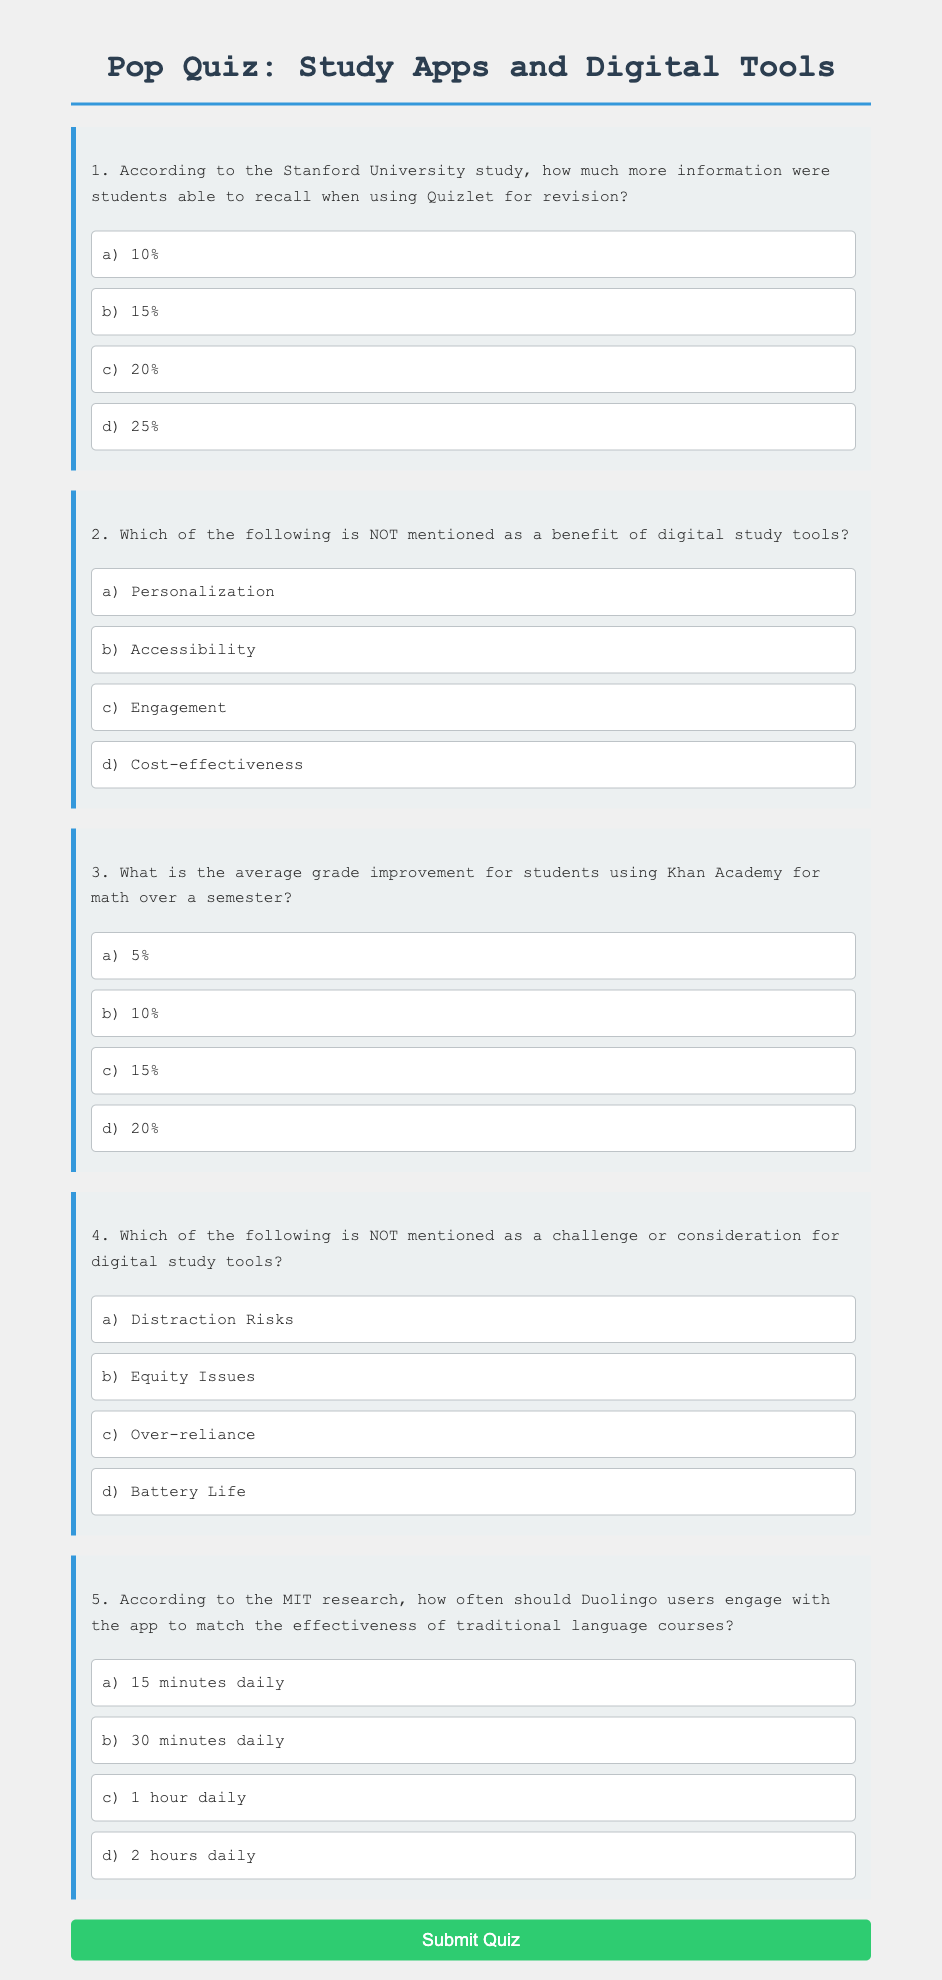What percentage increase in information recall is associated with Quizlet usage? The document states that students could recall 20% more information when using Quizlet for revision, according to a Stanford University study.
Answer: 20% What is the average grade improvement for students using Khan Academy in math? The document mentions that students using Khan Academy for math improved their grades by 15% over a semester.
Answer: 15% How many minutes daily should Duolingo users engage with the app to match traditional language course effectiveness? According to the document, Duolingo users should engage with the app for 30 minutes daily to match the effectiveness of traditional courses, as stated in MIT research.
Answer: 30 minutes What aspect of digital tools is NOT mentioned as a benefit in the document? The option 'Cost-effectiveness' is provided as an answer choice and is noted as not mentioned as a benefit of digital study tools.
Answer: Cost-effectiveness What challenge is cited in the document concerning digital study tools? The document lists 'Distraction Risks' as a challenge related to digital study tools, requiring students to manage their focus.
Answer: Distraction Risks 